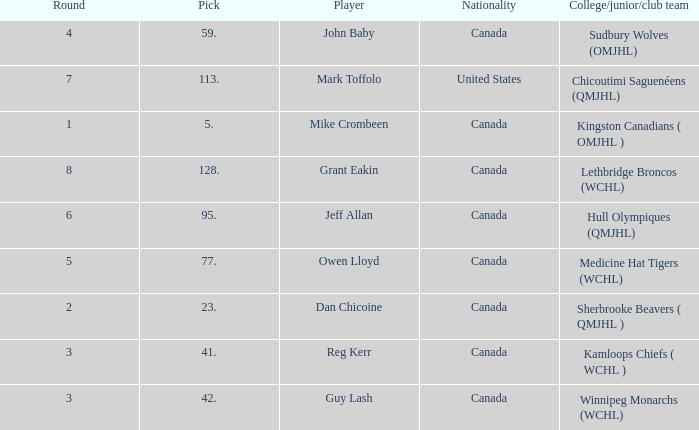Which College/junior/club team has a Round of 2? Sherbrooke Beavers ( QMJHL ). 